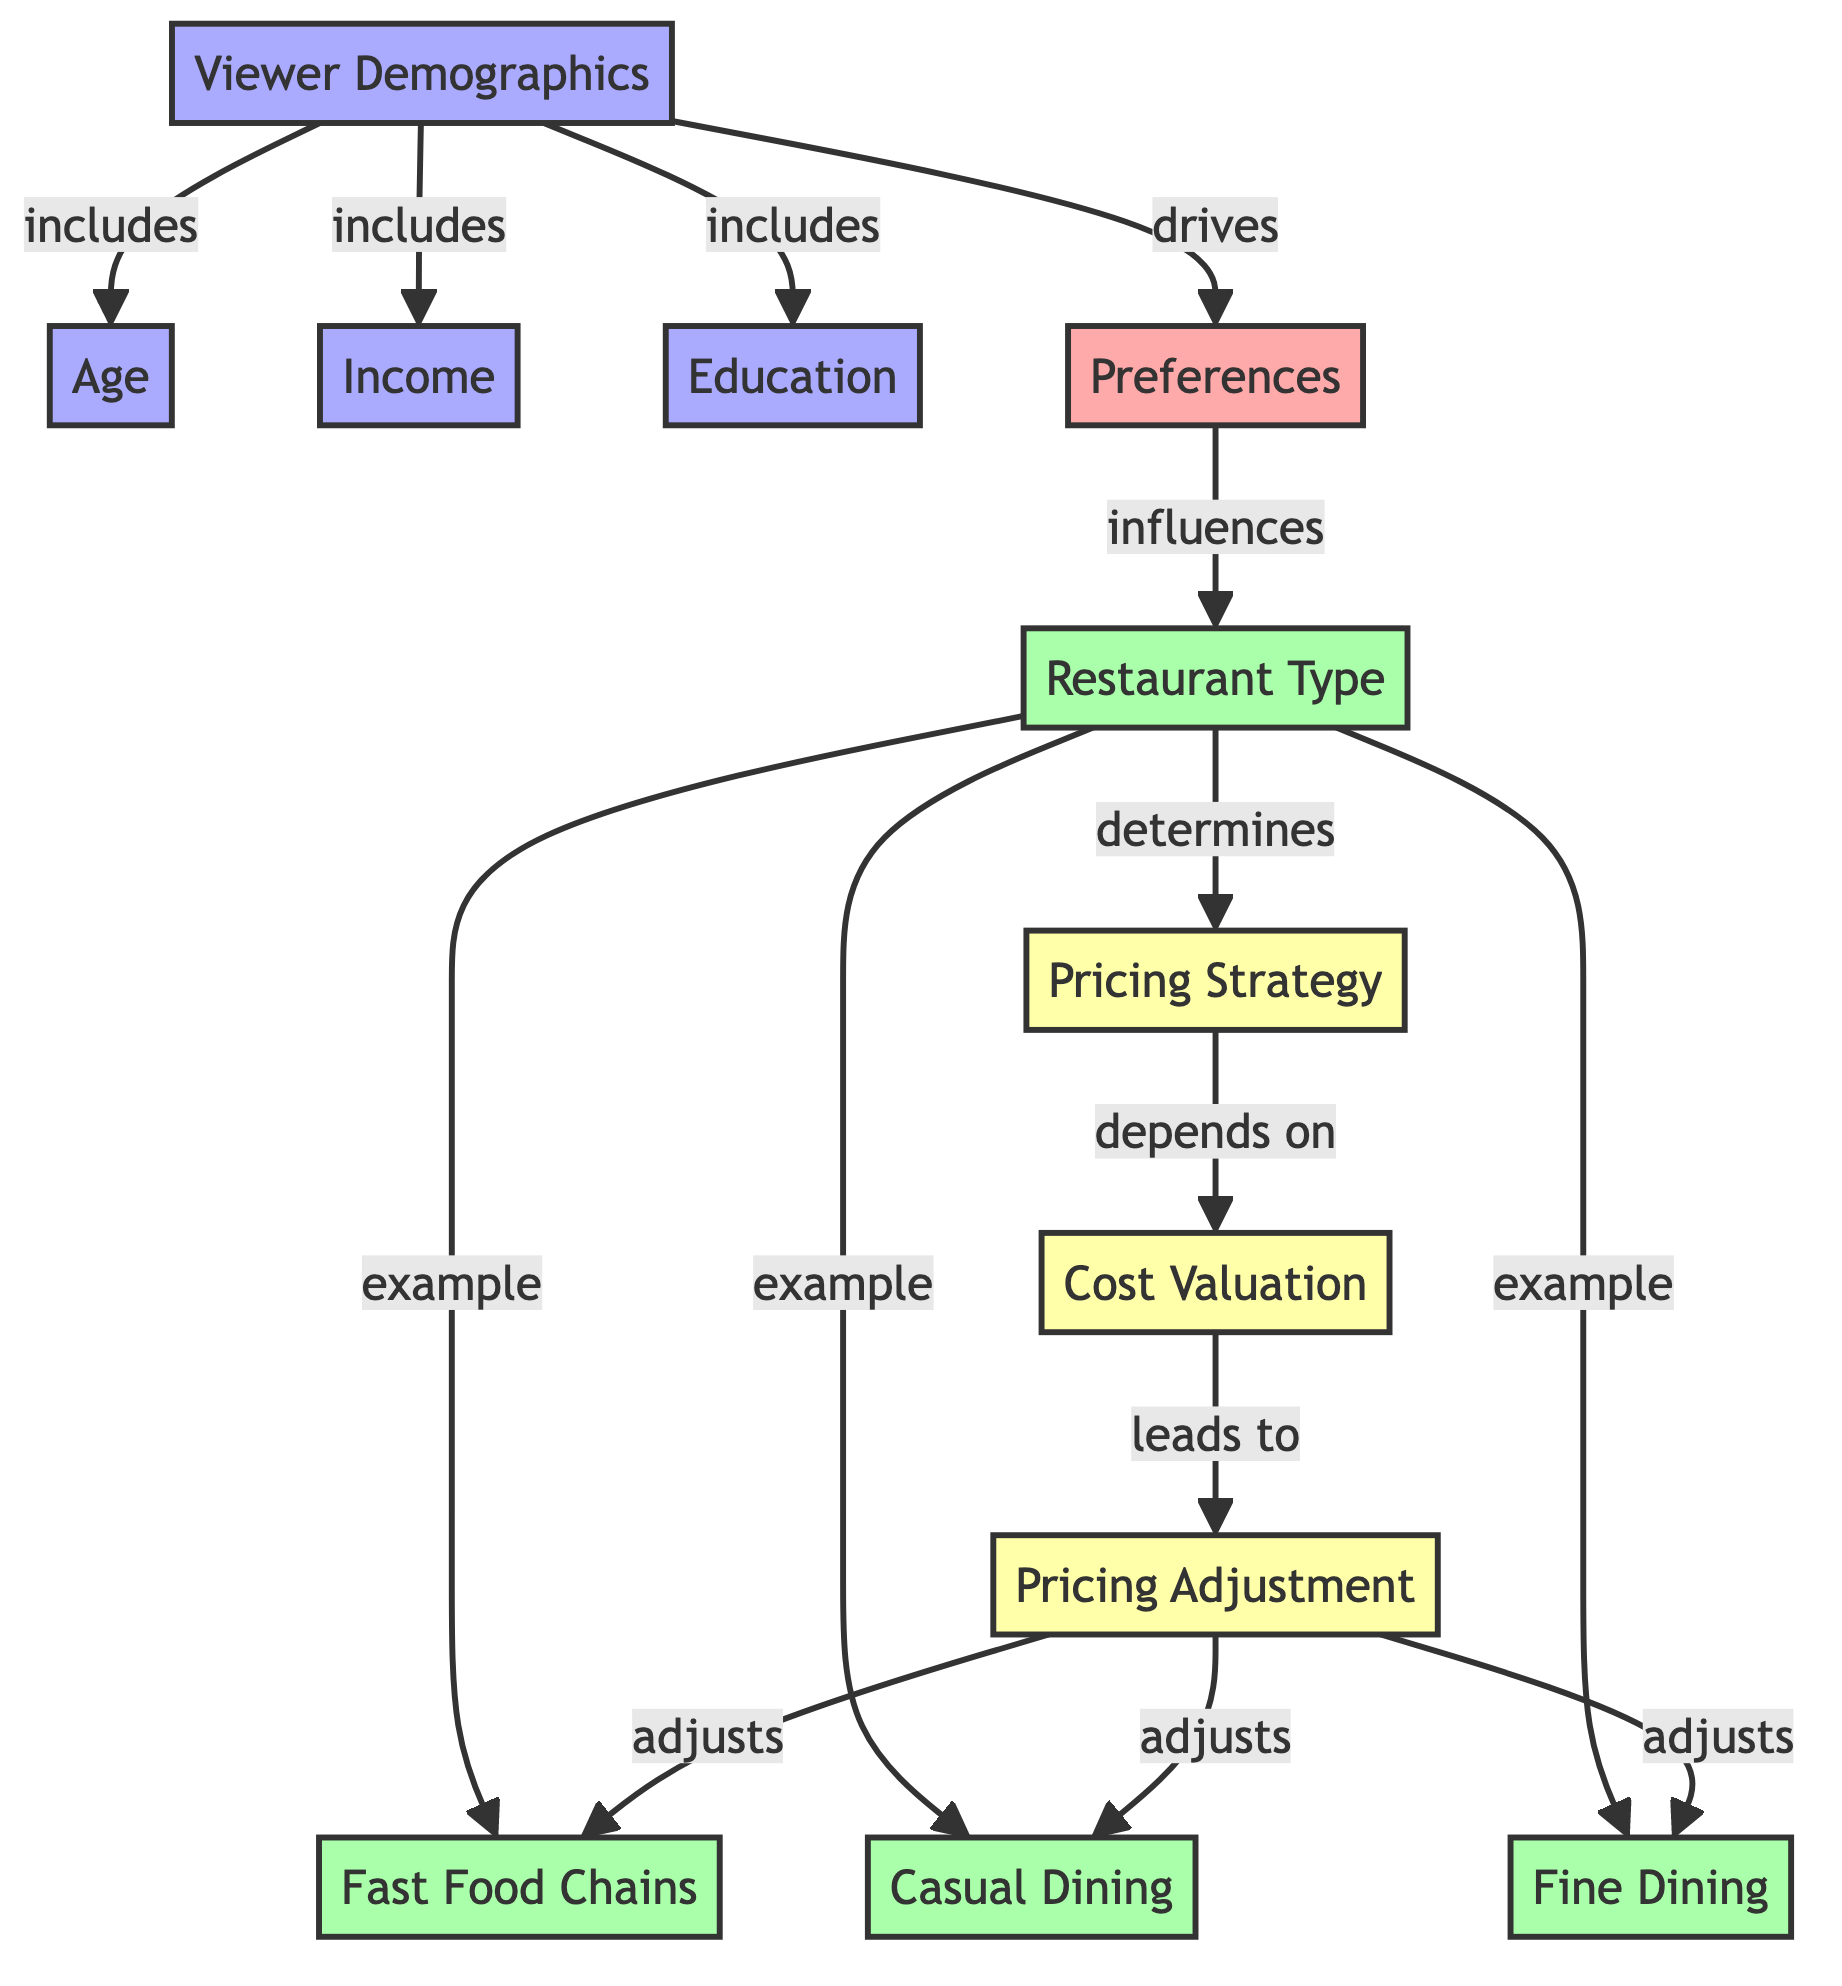What are the three aspects of viewer demographics? The diagram shows that viewer demographics include age, income, and education as its three aspects. This is directly stated in the relationships stemming from the viewer demographics node.
Answer: age, income, education Which restaurant type is an example of casual dining? The diagram specifically lists casual dining as one of the examples under the restaurant type category, indicating its classification without ambiguity.
Answer: casual dining What influences restaurant type? Preferences are shown to influence restaurant type, as indicated by the arrow pointing from the preferences node to the restaurant type node in the diagram.
Answer: preferences How many examples of restaurant types are listed? The diagram displays three examples of restaurant types: fast food, casual dining, and fine dining, which can be counted at their respective nodes.
Answer: three What determines pricing strategy? The restaurant type is indicated in the diagram as the determining factor for pricing strategy, highlighting the flow from restaurant type to pricing strategy.
Answer: restaurant type How does cost valuation affect pricing adjustment? The diagram illustrates that cost valuation leads to pricing adjustment, showing a direct causal relationship where understanding costs influences how prices are adjusted.
Answer: pricing adjustment Which viewer demographic drives preferences? The diagram indicates that viewer demographics drive preferences, with an arrow from the viewer demographics node pointing to the preferences node.
Answer: viewer demographics What is the outcome of pricing adjustment on restaurant types? The diagram shows that pricing adjustment adjusts fast food, casual dining, and fine dining, indicating that it influences prices across all three types.
Answer: fast food, casual dining, fine dining What is the relationship between dining type and pricing strategy? The relationship is that the restaurant type determines the pricing strategy, as depicted by the arrow leading from the restaurant type to the pricing strategy node in the diagram.
Answer: determines 